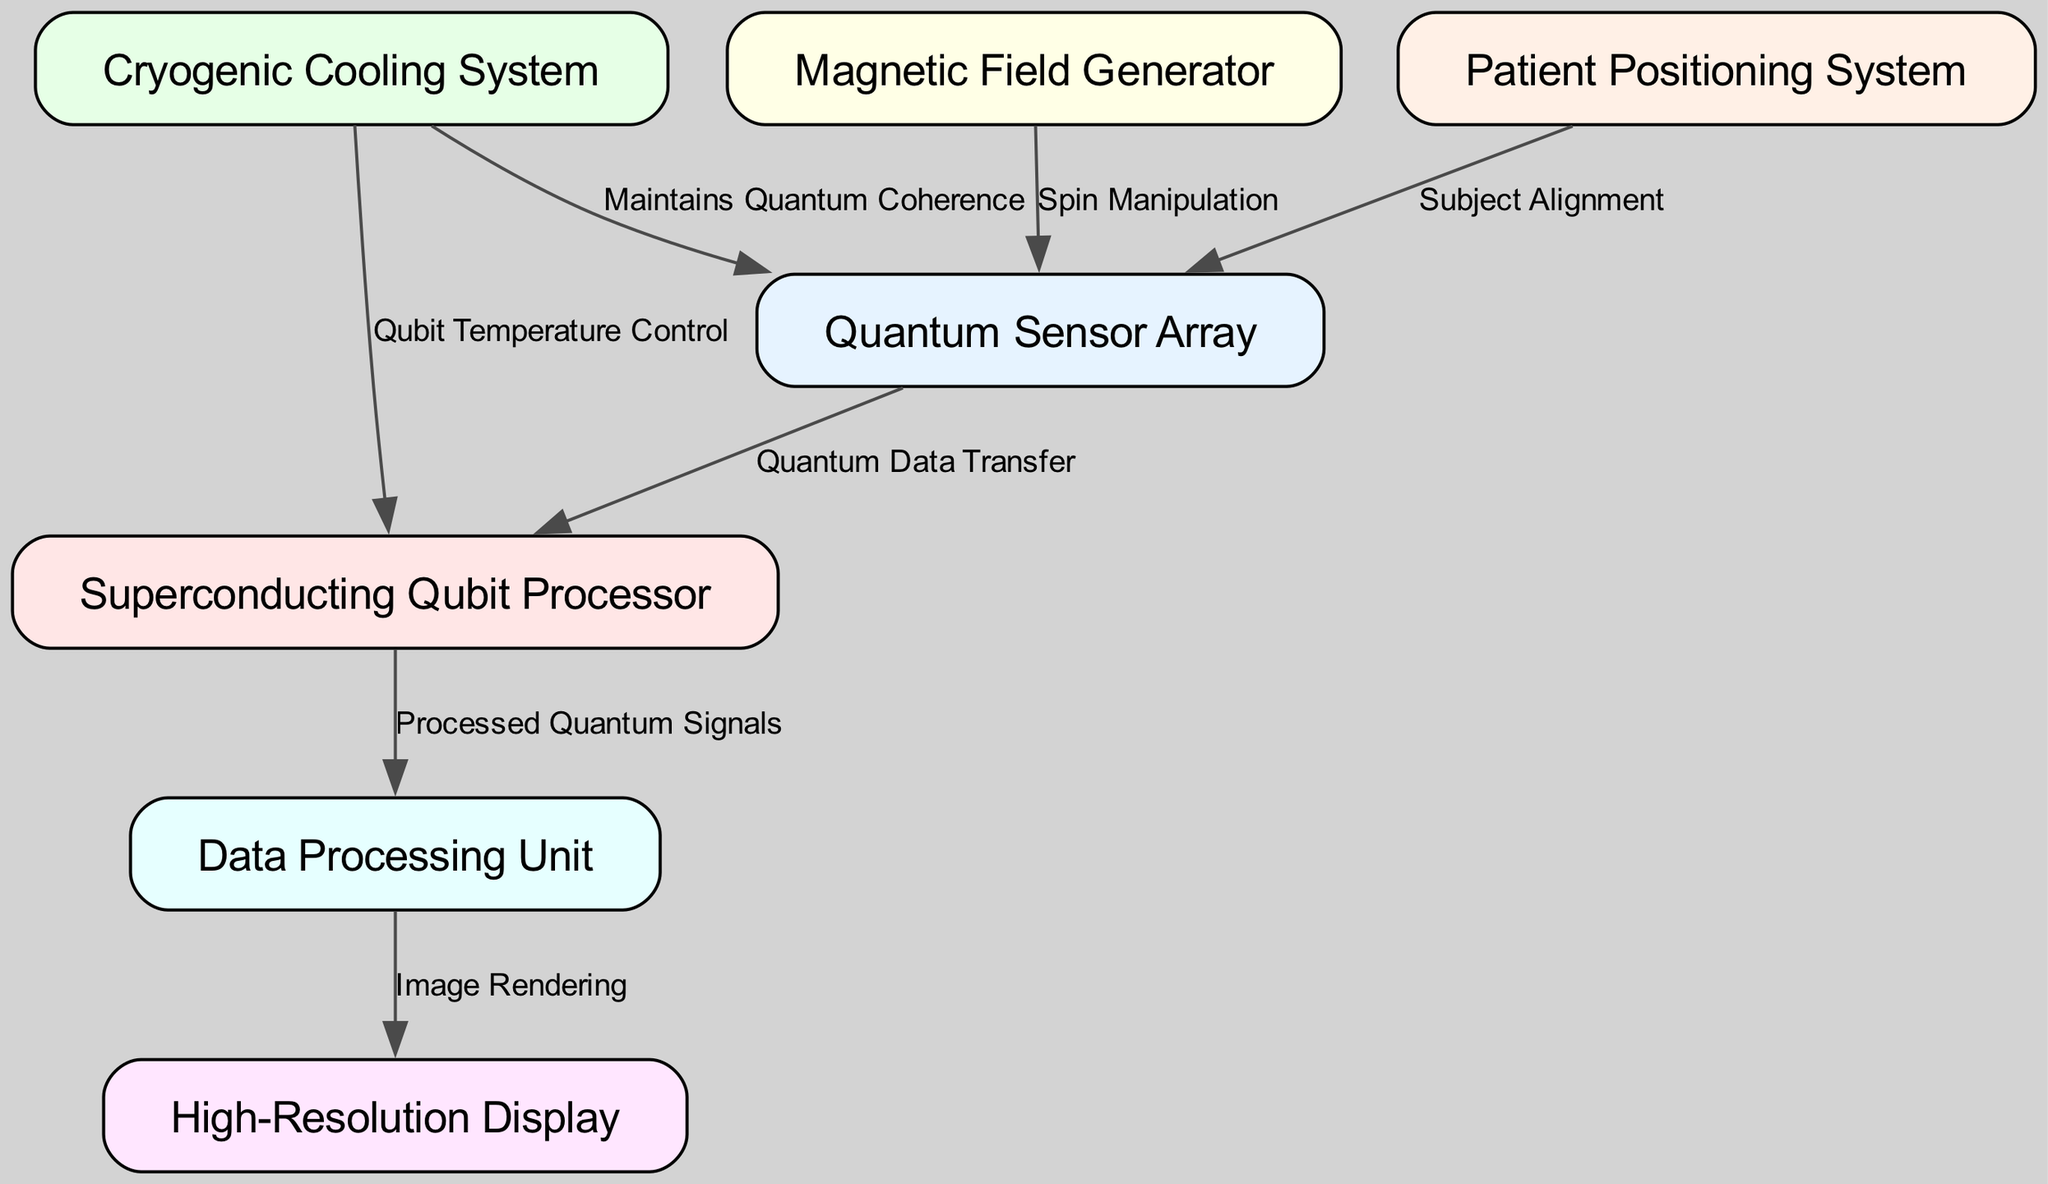What is the total number of nodes in the diagram? The diagram has a list of nodes provided in the data section. By counting the nodes listed, we can see there are seven distinct nodes.
Answer: 7 What type of system is id number 3? The label for node id number 3 is "Cryogenic Cooling System."
Answer: Cryogenic Cooling System Which node is connected to the High-Resolution Display? Observing the edges, the connection leading from Data Processing Unit (node id 6) to High-Resolution Display (node id 5) indicates that the High-Resolution Display receives its input from the Data Processing Unit.
Answer: Data Processing Unit What is the relationship type between the Quantum Sensor Array and the Superconducting Qubit Processor? The edge from node id 1 (Quantum Sensor Array) to node id 2 (Superconducting Qubit Processor) specifies the connection type as "Quantum Data Transfer."
Answer: Quantum Data Transfer Which two components are responsible for maintaining quantum properties and manipulating spins? Referring to the edges connected to the Quantum Sensor Array, the Cryogenic Cooling System (id 3) maintains quantum coherence, and the Magnetic Field Generator (id 4) is related to spin manipulation as indicated.
Answer: Cryogenic Cooling System, Magnetic Field Generator How many edges are there coming from the Quantum Sensor Array? By analyzing the outgoing connections from the Quantum Sensor Array (node id 1), we can see there are three edges leading to Superconducting Qubit Processor, Patient Positioning System, and the Magnetic Field Generator.
Answer: 3 What component interacts with the Qubit Temperature Control? The relationship indicates that the Cryogenic Cooling System (id 3) connects to the Superconducting Qubit Processor (id 2) through the edge labeled "Qubit Temperature Control."
Answer: Cryogenic Cooling System Which node provides Subject Alignment? Referring to the edge that originates from node id 7 (Patient Positioning System), it states that this component is responsible for subject alignment with Quantum Sensor Array.
Answer: Patient Positioning System Identify the main function of the Data Processing Unit. The Data Processing Unit (node id 6) is indicated to process the quantum signals received from the Superconducting Qubit Processor (node id 2), which implies its main function is to handle data processing.
Answer: Processed Quantum Signals 